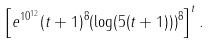<formula> <loc_0><loc_0><loc_500><loc_500>\left [ e ^ { 1 0 ^ { 1 2 } } ( t + 1 ) ^ { 8 } ( \log ( 5 ( t + 1 ) ) ) ^ { 8 } \right ] ^ { t } .</formula> 